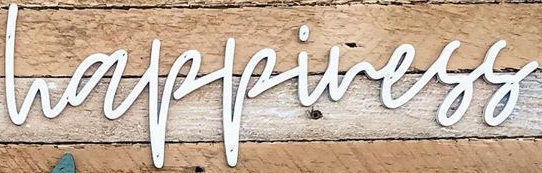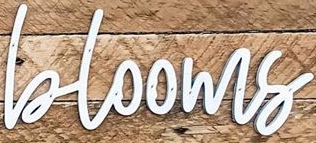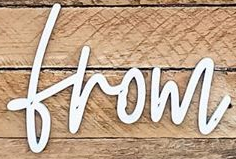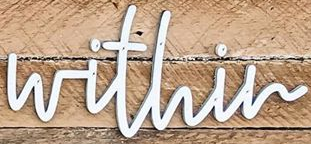Read the text content from these images in order, separated by a semicolon. happiness; blooms; from; within 